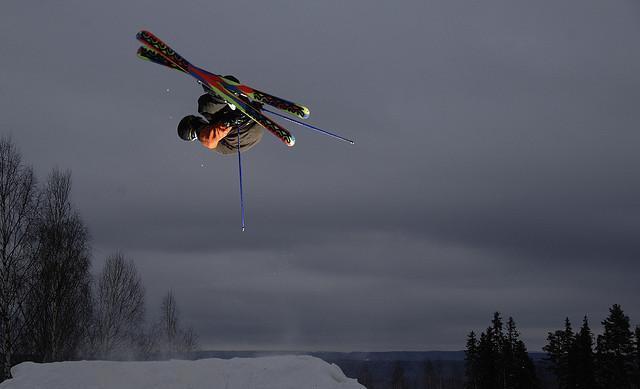How many mugs have a spoon resting inside them?
Give a very brief answer. 0. 